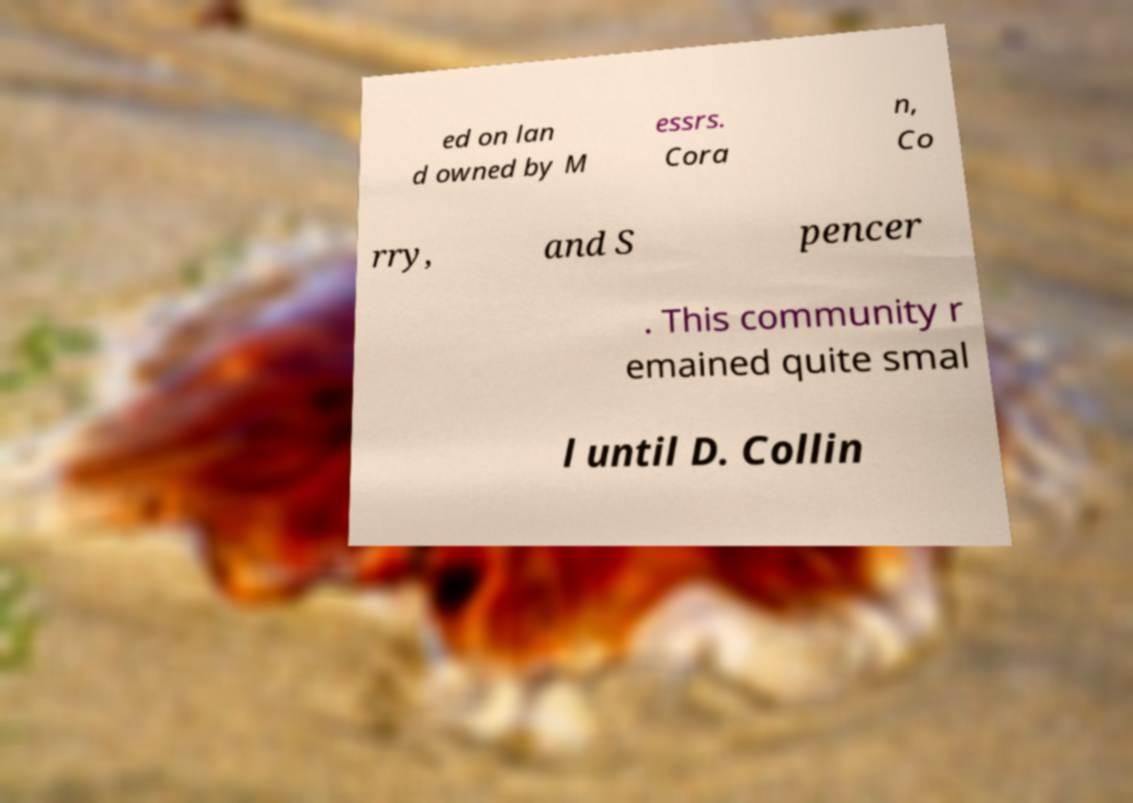I need the written content from this picture converted into text. Can you do that? ed on lan d owned by M essrs. Cora n, Co rry, and S pencer . This community r emained quite smal l until D. Collin 